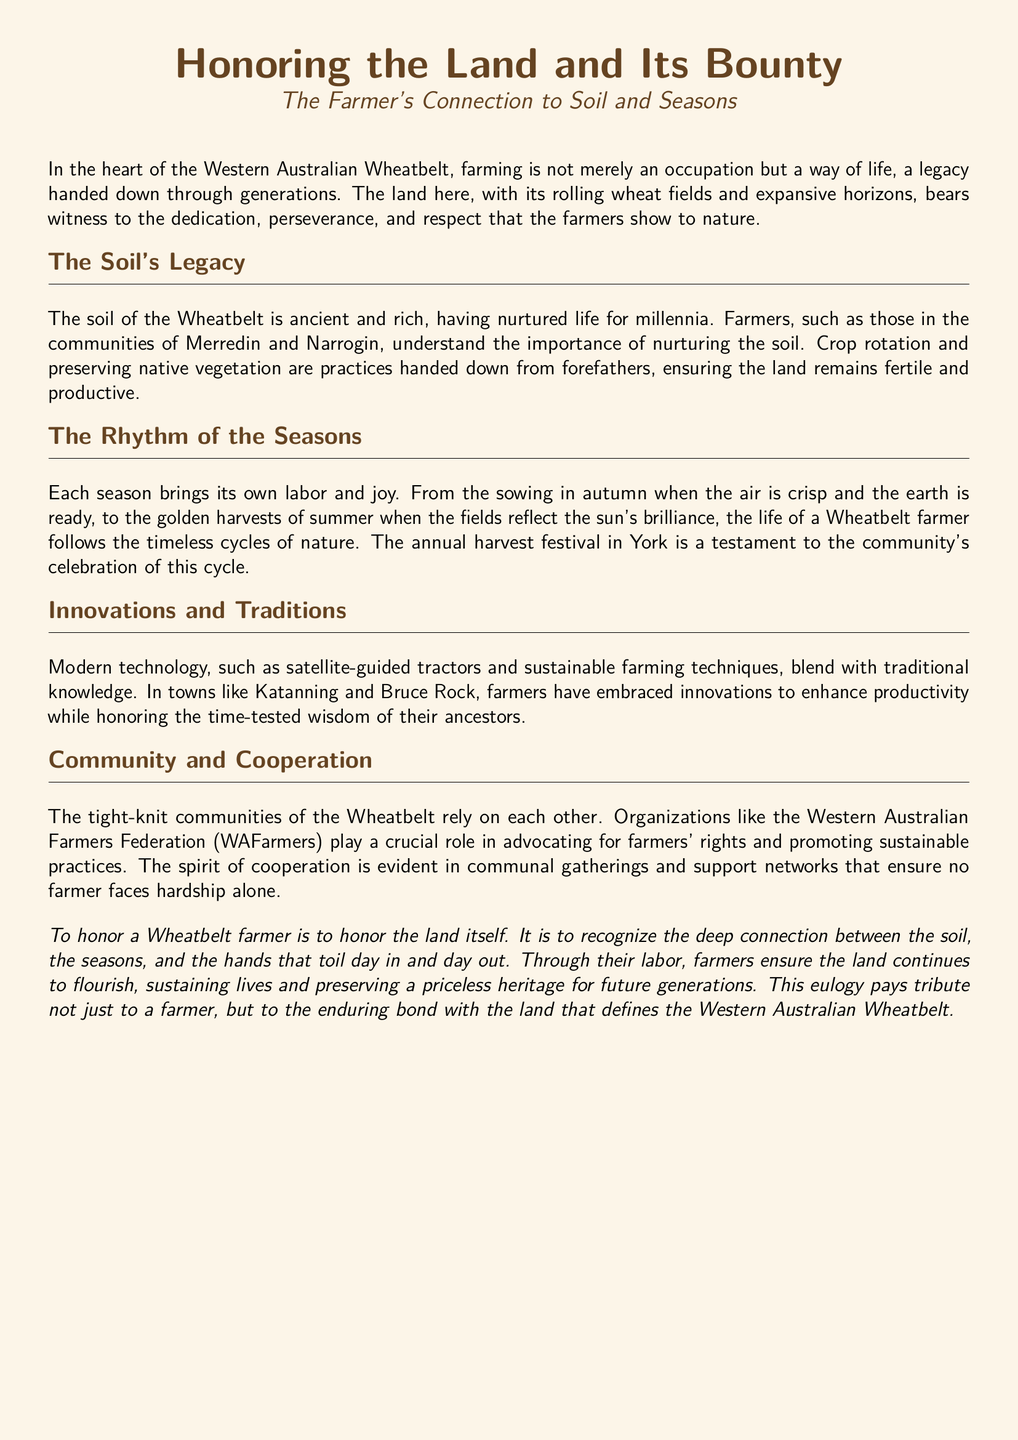What is the title of the document? The title is the main header of the eulogy, indicated prominently at the beginning.
Answer: Honoring the Land and Its Bounty Who are the farmers mentioned in the document? The document refers to farmers in specific communities located in the Wheatbelt.
Answer: Merredin and Narrogin What practices are emphasized for nurturing the soil? These practices are key methods for maintaining soil health, as mentioned in the section discussing legacy.
Answer: Crop rotation and preserving native vegetation What event is celebrated in York? This event highlights the community's recognition of the farming cycle and its importance to local culture.
Answer: Annual harvest festival Which towns embrace modern technology according to the document? These towns represent areas where farmers are combining modern techniques with traditional practices.
Answer: Katanning and Bruce Rock What organization is mentioned that advocates for farmers’ rights? This organization plays a significant role in supporting the farming community within the Wheatbelt.
Answer: Western Australian Farmers Federation What do the farmers ensure through their labor? This refers to the outcome of the farmers' dedication to the land and the community.
Answer: The land continues to flourish What is the main color used for the document background? This color impacts the aesthetics of the document and is indicative of the farming environment.
Answer: Wheat color What is the main theme of the eulogy? This overarching idea reflects the primary focus the eulogy aims to honor.
Answer: The connection between the soil, the seasons, and farmers 